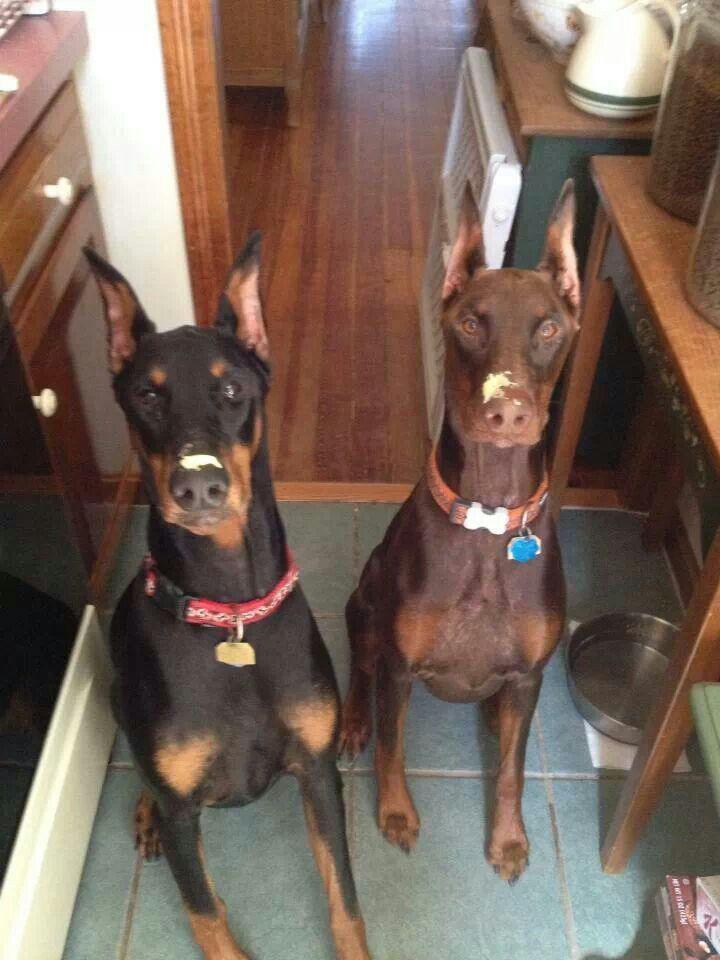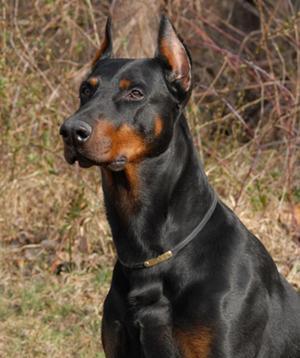The first image is the image on the left, the second image is the image on the right. Assess this claim about the two images: "Two images shown have one black and one brown doberman sitting together in the grass.". Correct or not? Answer yes or no. No. 